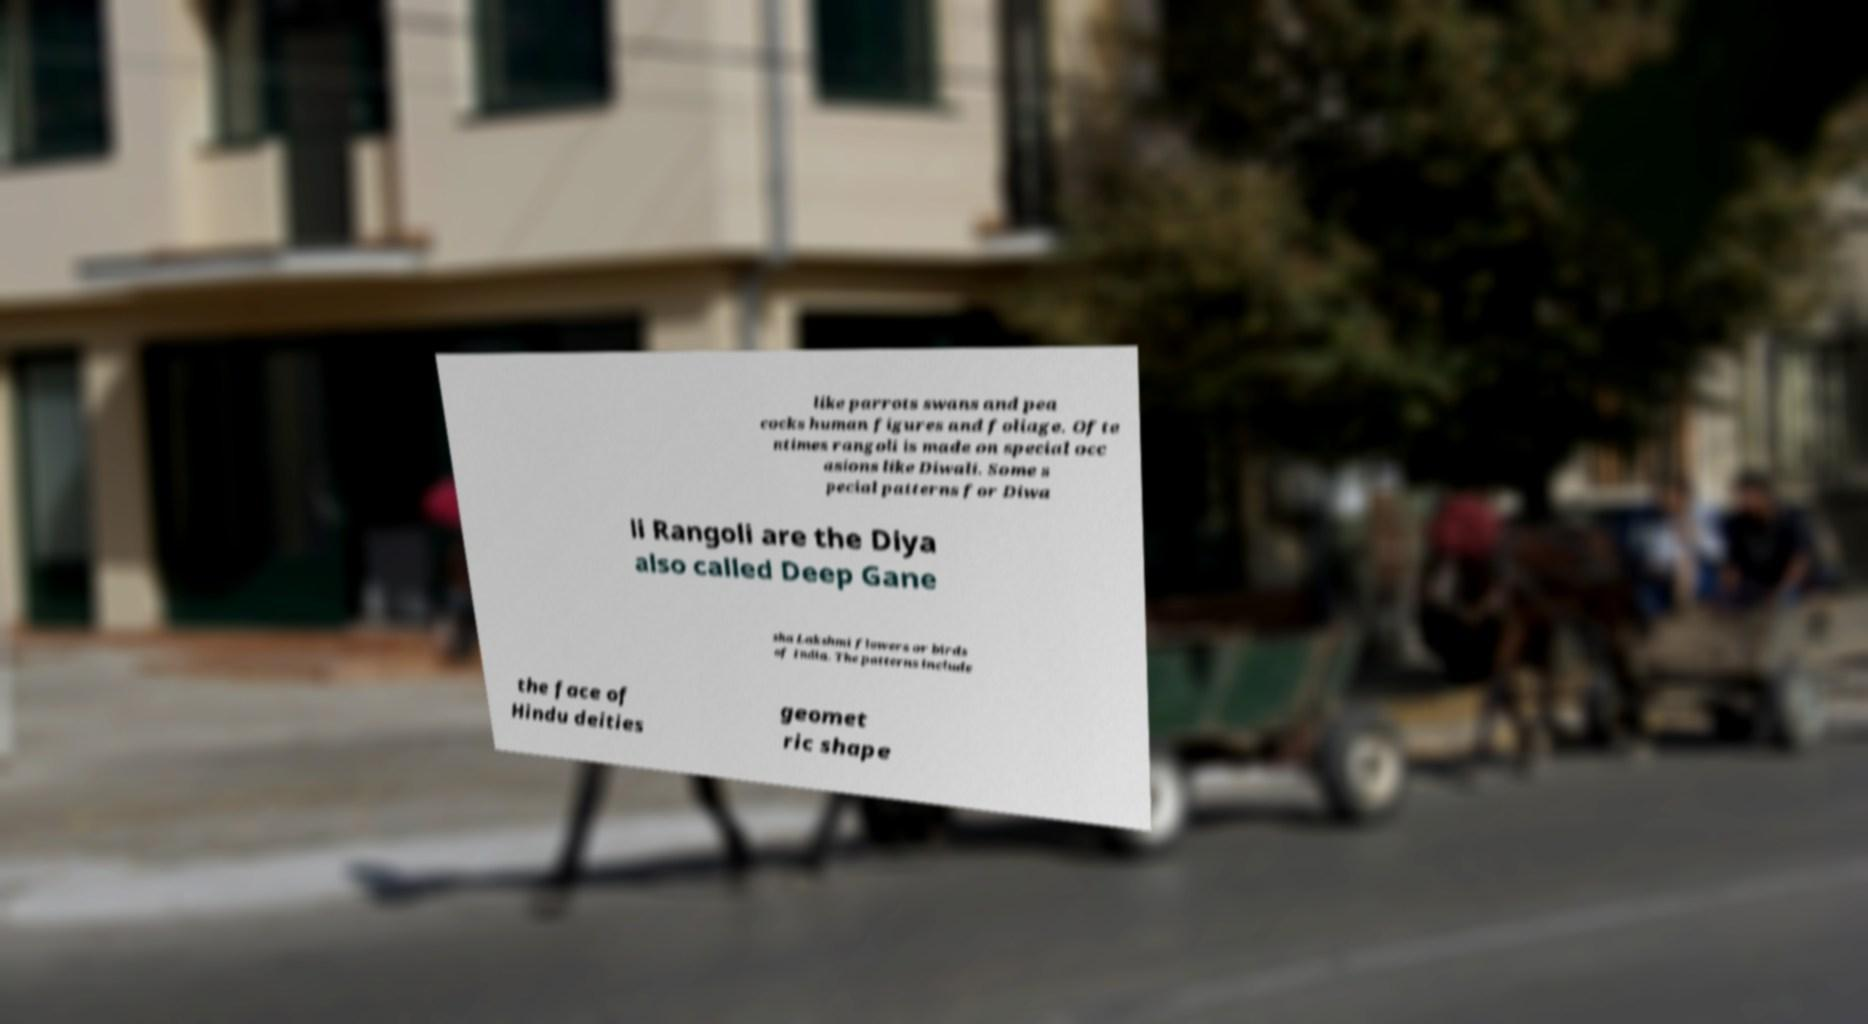What messages or text are displayed in this image? I need them in a readable, typed format. like parrots swans and pea cocks human figures and foliage. Ofte ntimes rangoli is made on special occ asions like Diwali. Some s pecial patterns for Diwa li Rangoli are the Diya also called Deep Gane sha Lakshmi flowers or birds of India. The patterns include the face of Hindu deities geomet ric shape 